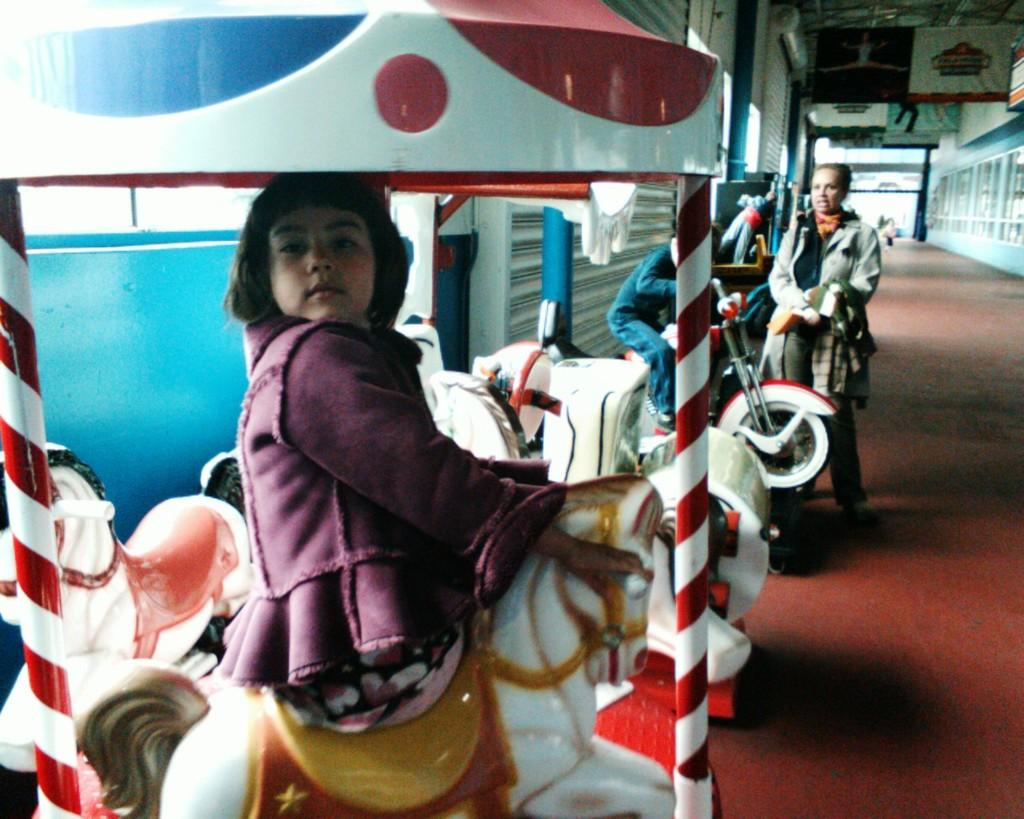What is the girl doing in the image? The girl is sitting on a toy horse. What is the woman holding in the image? The woman is holding a cloth. What is the kid doing in the image? The kid is sitting on a bike. What can be seen in the background of the image? There is a wall in the image. What decorative elements are present in the image? There are banners in the image. What surface is visible beneath the subjects in the image? There is a floor visible in the image. Can you see a snake slithering on the floor in the image? There is no snake present in the image; it only features a girl sitting on a toy horse, a woman holding a cloth, and a kid sitting on a bike. 